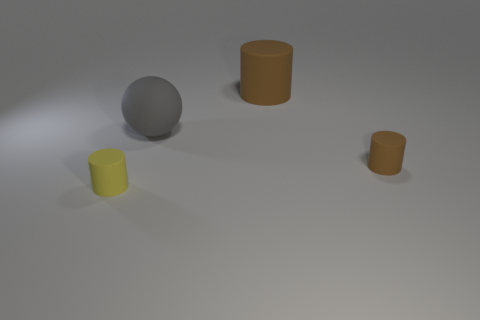Are there any cylinders?
Provide a short and direct response. Yes. There is another tiny thing that is the same shape as the tiny brown matte thing; what material is it?
Make the answer very short. Rubber. Are there any gray matte objects right of the small yellow matte cylinder?
Your answer should be very brief. Yes. Is there a small cylinder of the same color as the big matte cylinder?
Make the answer very short. Yes. What is the shape of the large gray matte thing?
Offer a terse response. Sphere. What color is the rubber cylinder behind the small brown cylinder that is behind the yellow cylinder?
Keep it short and to the point. Brown. What is the size of the brown object to the right of the big cylinder?
Keep it short and to the point. Small. Is there another big thing made of the same material as the big brown thing?
Offer a very short reply. Yes. How many yellow things have the same shape as the large brown matte thing?
Your answer should be compact. 1. There is a brown matte object that is right of the brown object that is left of the small object to the right of the big rubber cylinder; what shape is it?
Give a very brief answer. Cylinder. 